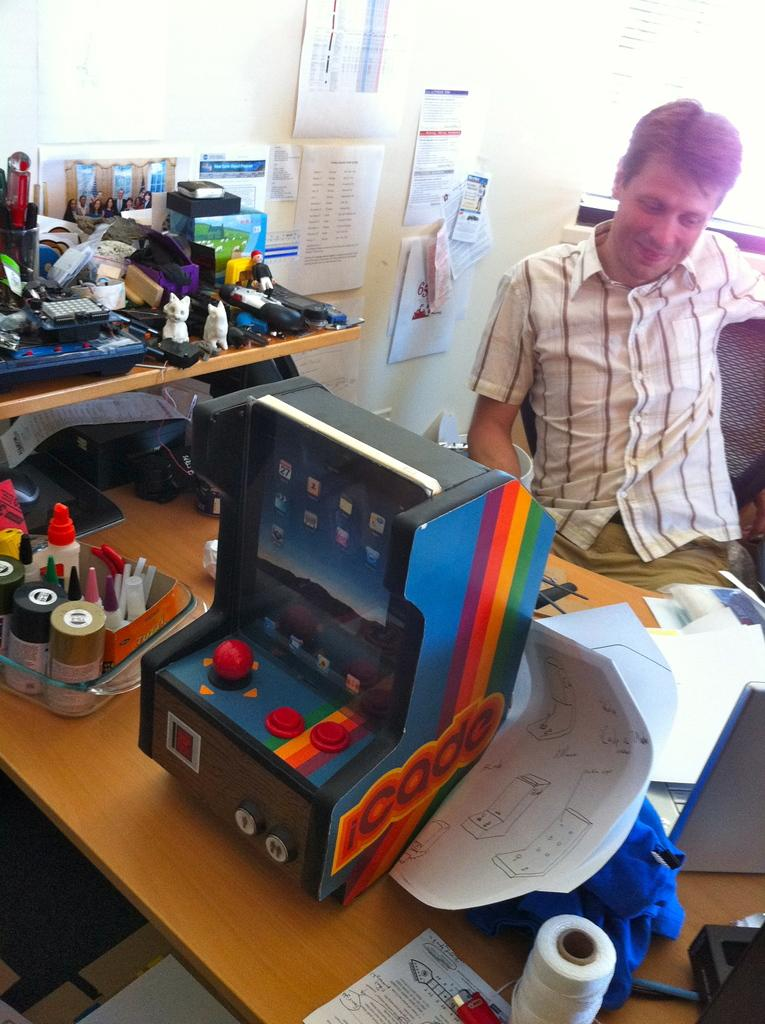Who is the main subject in the image? There is a man in the image. What is the man doing in the image? The man is sitting. What is the man's facial expression in the image? The man is smiling. What is in front of the man in the image? There is a table in front of the man. What can be seen on the table in the image? There are many things on the table. What is visible in the background of the image? There is a wall in the background of the image. What is on the wall in the image? There are papers on the wall. What type of shirt is the man's father wearing in the image? There is no mention of the man's father in the image, and therefore no shirt can be described. 